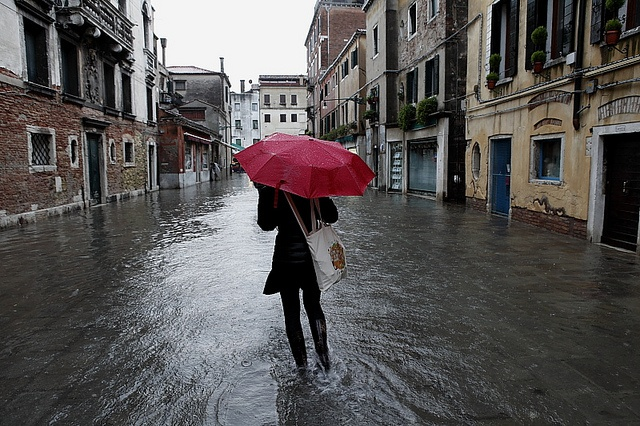Describe the objects in this image and their specific colors. I can see people in darkgray, black, gray, and maroon tones, umbrella in darkgray, maroon, and brown tones, handbag in darkgray, gray, black, and maroon tones, potted plant in darkgray, black, darkgreen, and gray tones, and potted plant in darkgray, black, darkgreen, and gray tones in this image. 